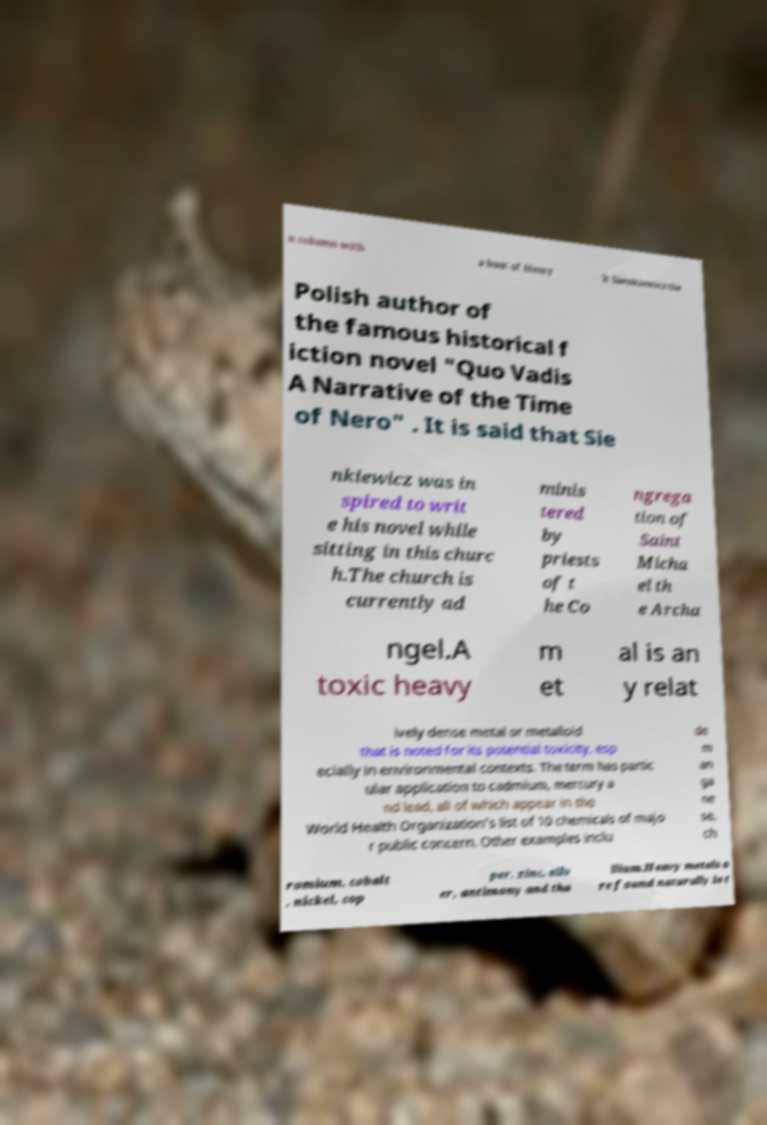Can you accurately transcribe the text from the provided image for me? n column with a bust of Henry k Sienkiewicz the Polish author of the famous historical f iction novel "Quo Vadis A Narrative of the Time of Nero" . It is said that Sie nkiewicz was in spired to writ e his novel while sitting in this churc h.The church is currently ad minis tered by priests of t he Co ngrega tion of Saint Micha el th e Archa ngel.A toxic heavy m et al is an y relat ively dense metal or metalloid that is noted for its potential toxicity, esp ecially in environmental contexts. The term has partic ular application to cadmium, mercury a nd lead, all of which appear in the World Health Organization's list of 10 chemicals of majo r public concern. Other examples inclu de m an ga ne se, ch romium, cobalt , nickel, cop per, zinc, silv er, antimony and tha llium.Heavy metals a re found naturally in t 